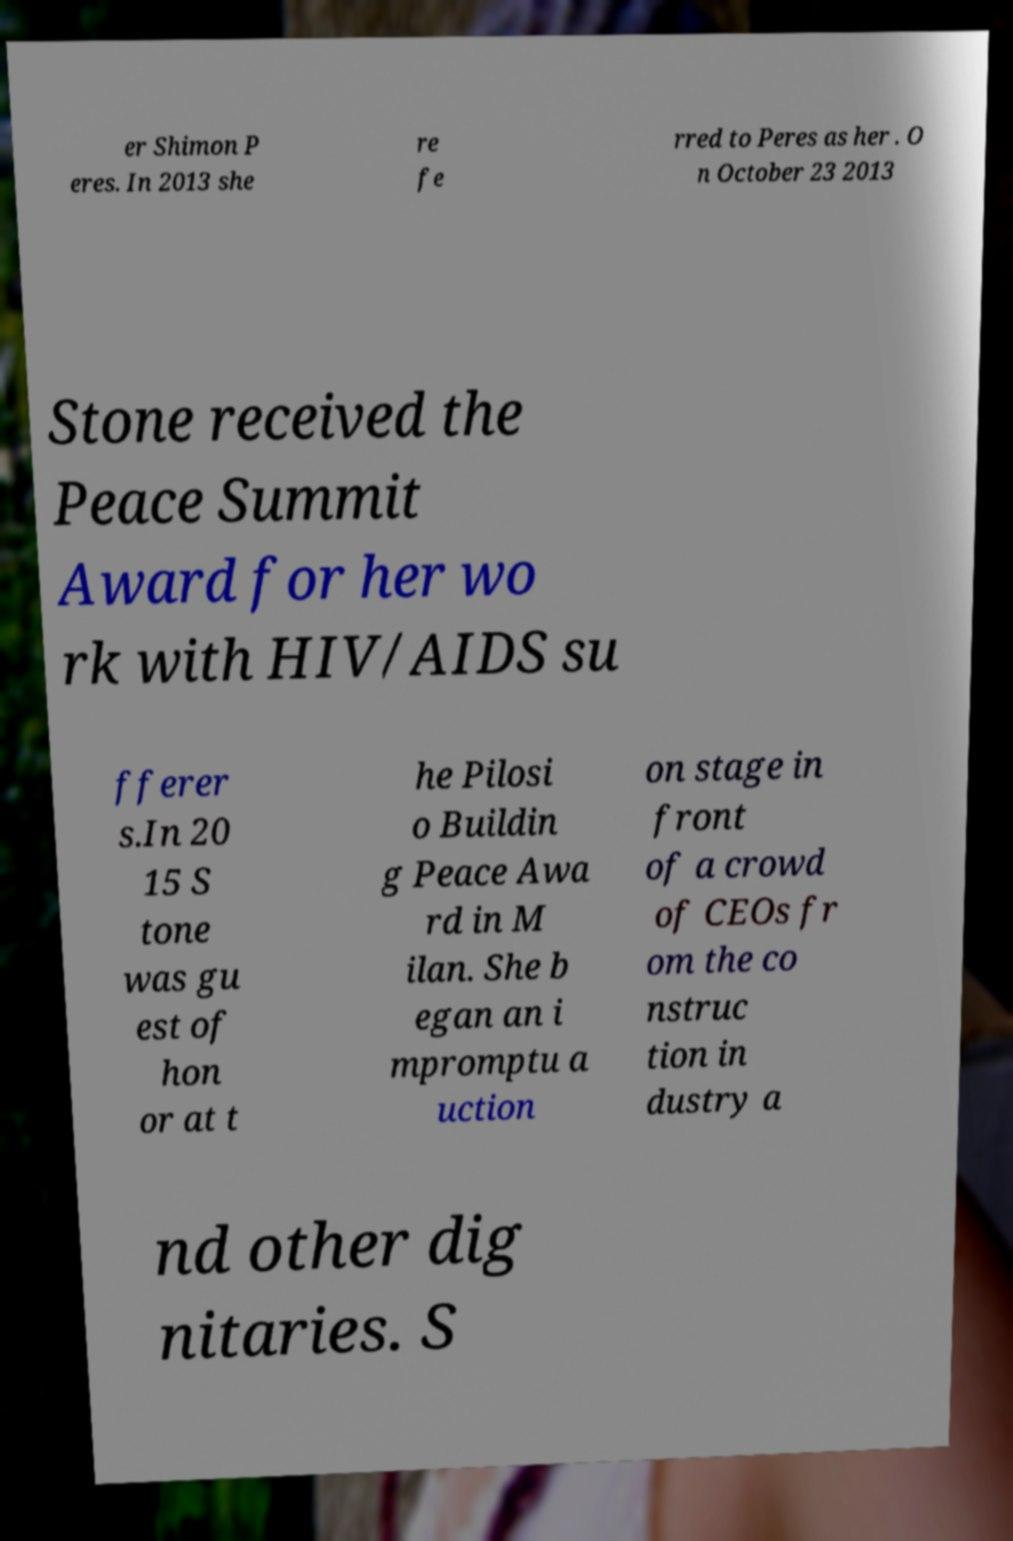Could you assist in decoding the text presented in this image and type it out clearly? er Shimon P eres. In 2013 she re fe rred to Peres as her . O n October 23 2013 Stone received the Peace Summit Award for her wo rk with HIV/AIDS su fferer s.In 20 15 S tone was gu est of hon or at t he Pilosi o Buildin g Peace Awa rd in M ilan. She b egan an i mpromptu a uction on stage in front of a crowd of CEOs fr om the co nstruc tion in dustry a nd other dig nitaries. S 